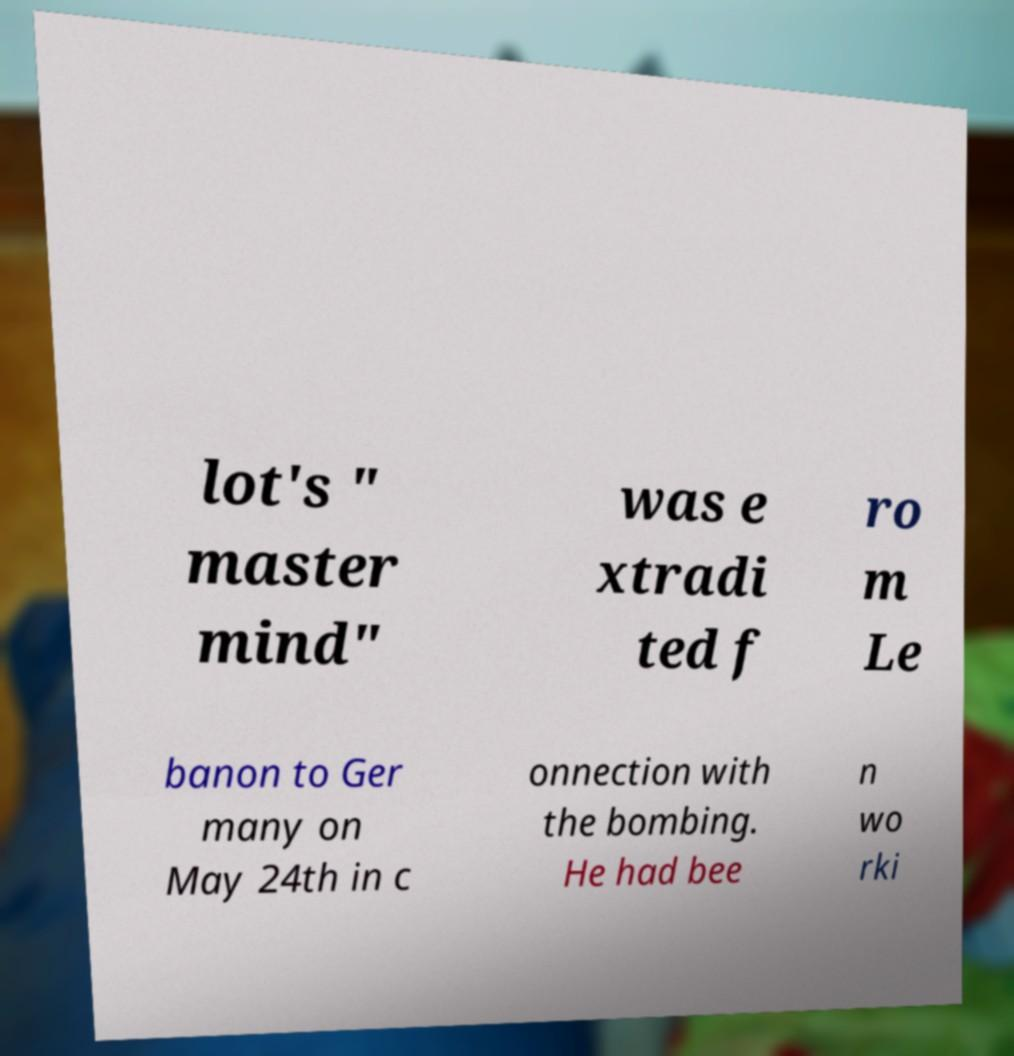Could you assist in decoding the text presented in this image and type it out clearly? lot's " master mind" was e xtradi ted f ro m Le banon to Ger many on May 24th in c onnection with the bombing. He had bee n wo rki 